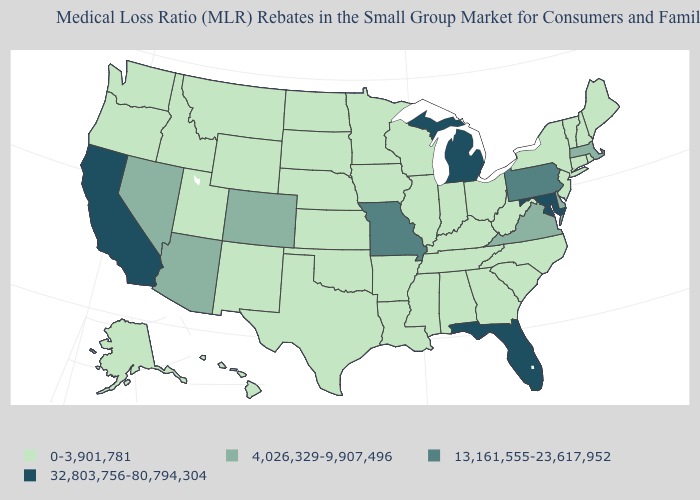What is the value of Massachusetts?
Write a very short answer. 4,026,329-9,907,496. Does Iowa have the lowest value in the MidWest?
Keep it brief. Yes. Name the states that have a value in the range 4,026,329-9,907,496?
Keep it brief. Arizona, Colorado, Delaware, Massachusetts, Nevada, Virginia. What is the highest value in the Northeast ?
Concise answer only. 13,161,555-23,617,952. Does Florida have the highest value in the USA?
Write a very short answer. Yes. Which states have the lowest value in the USA?
Short answer required. Alabama, Alaska, Arkansas, Connecticut, Georgia, Hawaii, Idaho, Illinois, Indiana, Iowa, Kansas, Kentucky, Louisiana, Maine, Minnesota, Mississippi, Montana, Nebraska, New Hampshire, New Jersey, New Mexico, New York, North Carolina, North Dakota, Ohio, Oklahoma, Oregon, Rhode Island, South Carolina, South Dakota, Tennessee, Texas, Utah, Vermont, Washington, West Virginia, Wisconsin, Wyoming. Does Mississippi have the highest value in the South?
Give a very brief answer. No. Does Arizona have the same value as Massachusetts?
Be succinct. Yes. Name the states that have a value in the range 0-3,901,781?
Concise answer only. Alabama, Alaska, Arkansas, Connecticut, Georgia, Hawaii, Idaho, Illinois, Indiana, Iowa, Kansas, Kentucky, Louisiana, Maine, Minnesota, Mississippi, Montana, Nebraska, New Hampshire, New Jersey, New Mexico, New York, North Carolina, North Dakota, Ohio, Oklahoma, Oregon, Rhode Island, South Carolina, South Dakota, Tennessee, Texas, Utah, Vermont, Washington, West Virginia, Wisconsin, Wyoming. Which states have the lowest value in the USA?
Quick response, please. Alabama, Alaska, Arkansas, Connecticut, Georgia, Hawaii, Idaho, Illinois, Indiana, Iowa, Kansas, Kentucky, Louisiana, Maine, Minnesota, Mississippi, Montana, Nebraska, New Hampshire, New Jersey, New Mexico, New York, North Carolina, North Dakota, Ohio, Oklahoma, Oregon, Rhode Island, South Carolina, South Dakota, Tennessee, Texas, Utah, Vermont, Washington, West Virginia, Wisconsin, Wyoming. What is the highest value in the South ?
Short answer required. 32,803,756-80,794,304. Does the first symbol in the legend represent the smallest category?
Short answer required. Yes. Name the states that have a value in the range 13,161,555-23,617,952?
Keep it brief. Missouri, Pennsylvania. Name the states that have a value in the range 0-3,901,781?
Quick response, please. Alabama, Alaska, Arkansas, Connecticut, Georgia, Hawaii, Idaho, Illinois, Indiana, Iowa, Kansas, Kentucky, Louisiana, Maine, Minnesota, Mississippi, Montana, Nebraska, New Hampshire, New Jersey, New Mexico, New York, North Carolina, North Dakota, Ohio, Oklahoma, Oregon, Rhode Island, South Carolina, South Dakota, Tennessee, Texas, Utah, Vermont, Washington, West Virginia, Wisconsin, Wyoming. Name the states that have a value in the range 0-3,901,781?
Give a very brief answer. Alabama, Alaska, Arkansas, Connecticut, Georgia, Hawaii, Idaho, Illinois, Indiana, Iowa, Kansas, Kentucky, Louisiana, Maine, Minnesota, Mississippi, Montana, Nebraska, New Hampshire, New Jersey, New Mexico, New York, North Carolina, North Dakota, Ohio, Oklahoma, Oregon, Rhode Island, South Carolina, South Dakota, Tennessee, Texas, Utah, Vermont, Washington, West Virginia, Wisconsin, Wyoming. 